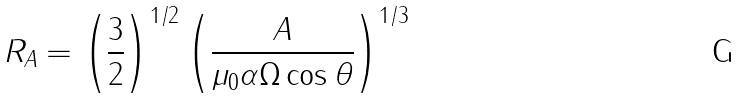<formula> <loc_0><loc_0><loc_500><loc_500>R _ { A } = \left ( \frac { 3 } { 2 } \right ) ^ { 1 / 2 } \left ( \frac { A } { \mu _ { 0 } \alpha \Omega \cos \theta } \right ) ^ { 1 / 3 }</formula> 